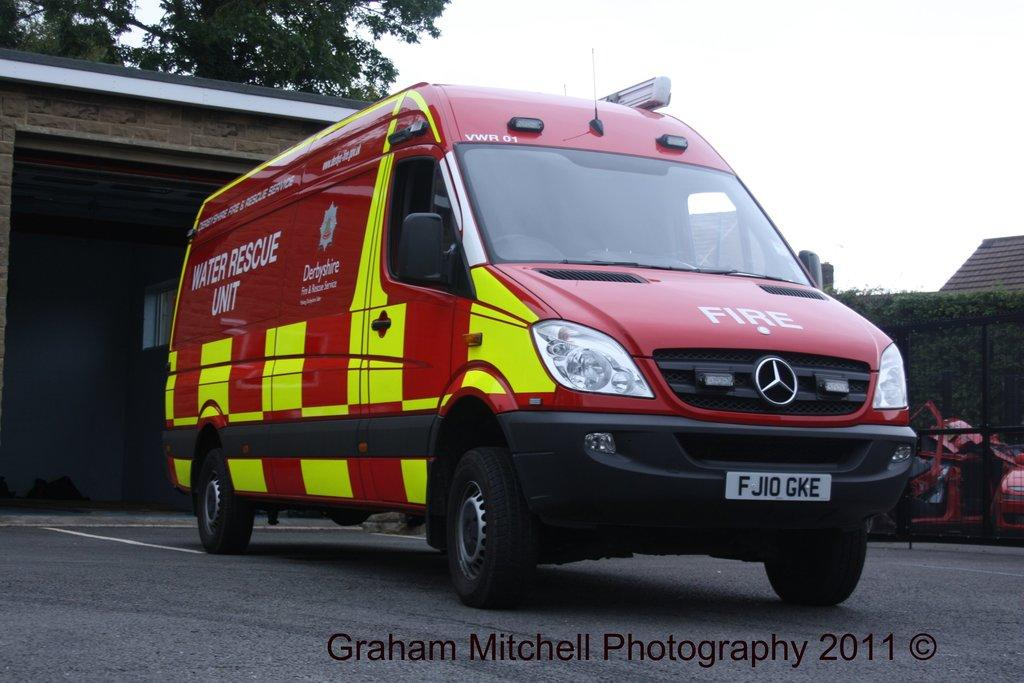<image>
Write a terse but informative summary of the picture. A large, red emergency vehicle with "fire" on the front and "water rescue unit" on the side. 